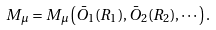<formula> <loc_0><loc_0><loc_500><loc_500>M _ { \mu } = M _ { \mu } \left ( \bar { O } _ { 1 } ( R _ { 1 } ) , \bar { O } _ { 2 } ( R _ { 2 } ) , \cdots \right ) .</formula> 